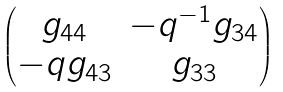<formula> <loc_0><loc_0><loc_500><loc_500>\begin{pmatrix} g _ { 4 4 } & - q ^ { - 1 } g _ { 3 4 } \\ - q g _ { 4 3 } & g _ { 3 3 } \end{pmatrix}</formula> 